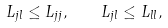Convert formula to latex. <formula><loc_0><loc_0><loc_500><loc_500>L _ { j l } \leq L _ { j j } , \quad L _ { j l } \leq L _ { l l } ,</formula> 